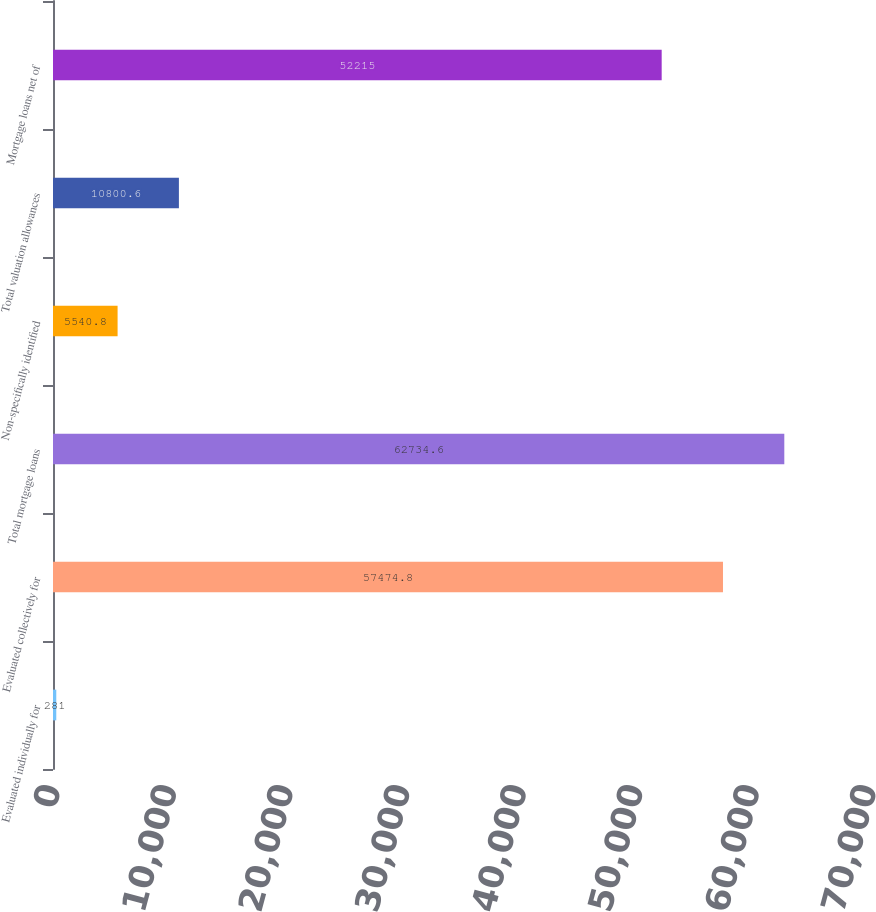Convert chart. <chart><loc_0><loc_0><loc_500><loc_500><bar_chart><fcel>Evaluated individually for<fcel>Evaluated collectively for<fcel>Total mortgage loans<fcel>Non-specifically identified<fcel>Total valuation allowances<fcel>Mortgage loans net of<nl><fcel>281<fcel>57474.8<fcel>62734.6<fcel>5540.8<fcel>10800.6<fcel>52215<nl></chart> 